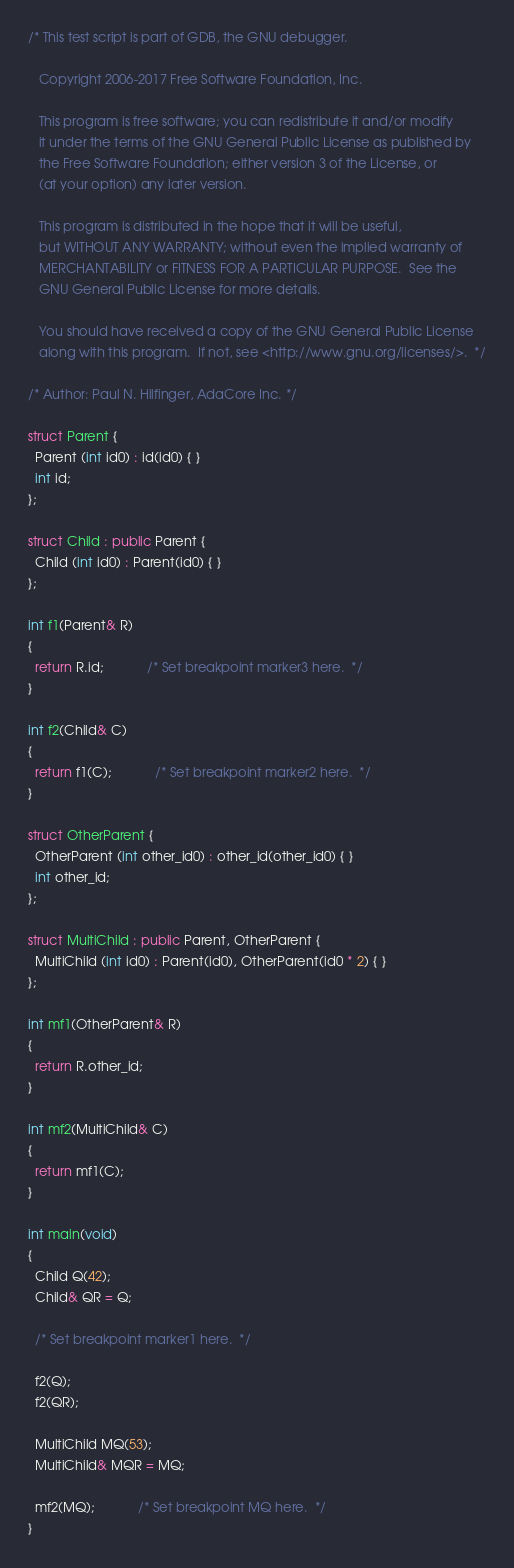<code> <loc_0><loc_0><loc_500><loc_500><_C++_>/* This test script is part of GDB, the GNU debugger.

   Copyright 2006-2017 Free Software Foundation, Inc.

   This program is free software; you can redistribute it and/or modify
   it under the terms of the GNU General Public License as published by
   the Free Software Foundation; either version 3 of the License, or
   (at your option) any later version.

   This program is distributed in the hope that it will be useful,
   but WITHOUT ANY WARRANTY; without even the implied warranty of
   MERCHANTABILITY or FITNESS FOR A PARTICULAR PURPOSE.  See the
   GNU General Public License for more details.

   You should have received a copy of the GNU General Public License
   along with this program.  If not, see <http://www.gnu.org/licenses/>.  */

/* Author: Paul N. Hilfinger, AdaCore Inc. */

struct Parent {
  Parent (int id0) : id(id0) { }
  int id;
};

struct Child : public Parent {
  Child (int id0) : Parent(id0) { }
};

int f1(Parent& R)
{
  return R.id;			/* Set breakpoint marker3 here.  */
}

int f2(Child& C)
{
  return f1(C);			/* Set breakpoint marker2 here.  */
}

struct OtherParent {
  OtherParent (int other_id0) : other_id(other_id0) { }
  int other_id;
};

struct MultiChild : public Parent, OtherParent {
  MultiChild (int id0) : Parent(id0), OtherParent(id0 * 2) { }
};

int mf1(OtherParent& R)
{
  return R.other_id;
}

int mf2(MultiChild& C)
{
  return mf1(C);
}

int main(void) 
{
  Child Q(42);
  Child& QR = Q;

  /* Set breakpoint marker1 here.  */

  f2(Q);
  f2(QR);

  MultiChild MQ(53);
  MultiChild& MQR = MQ;

  mf2(MQ);			/* Set breakpoint MQ here.  */
}
</code> 